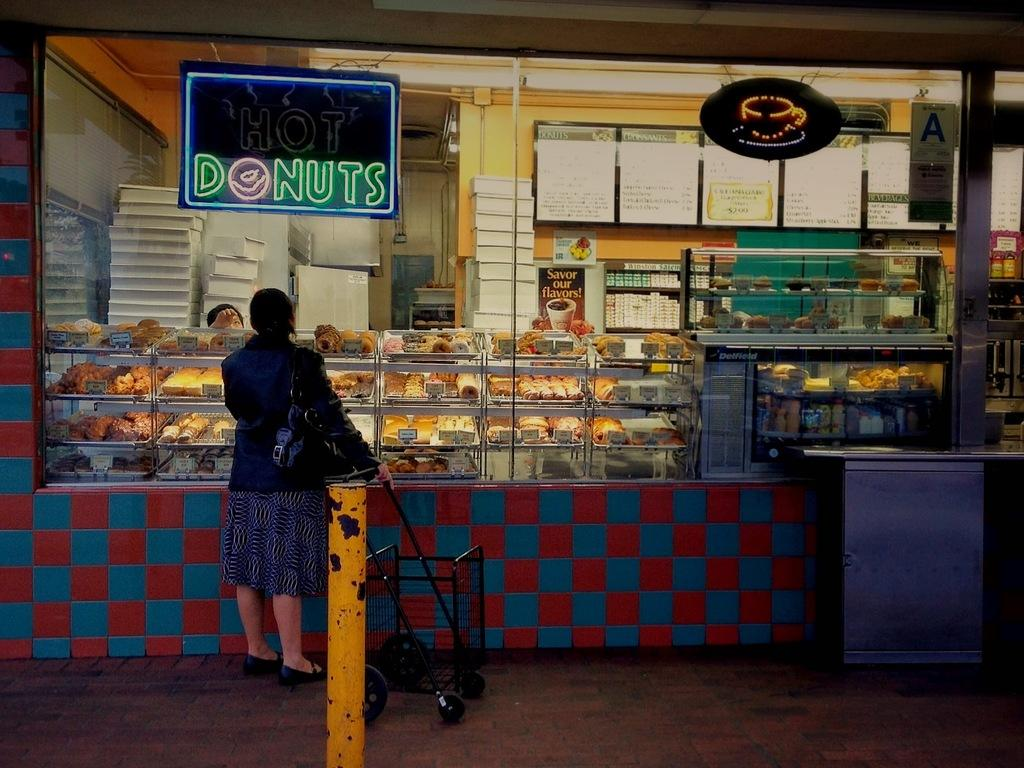<image>
Create a compact narrative representing the image presented. A person is ordering donuts at a cafe 